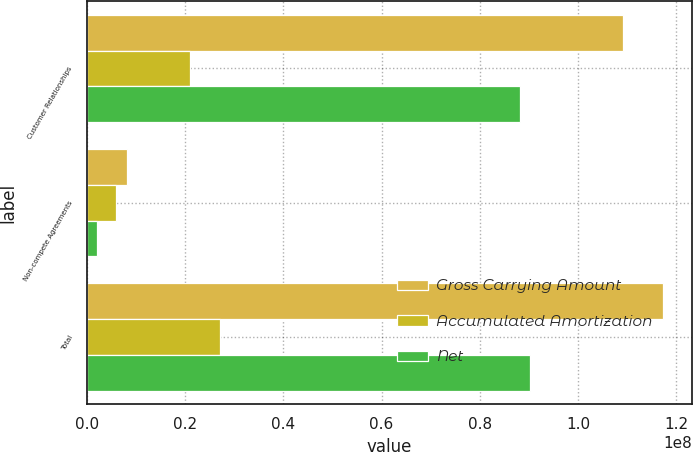Convert chart. <chart><loc_0><loc_0><loc_500><loc_500><stacked_bar_chart><ecel><fcel>Customer Relationships<fcel>Non-compete Agreements<fcel>Total<nl><fcel>Gross Carrying Amount<fcel>1.09201e+08<fcel>8.099e+06<fcel>1.173e+08<nl><fcel>Accumulated Amortization<fcel>2.1056e+07<fcel>6.001e+06<fcel>2.7057e+07<nl><fcel>Net<fcel>8.8145e+07<fcel>2.098e+06<fcel>9.0243e+07<nl></chart> 